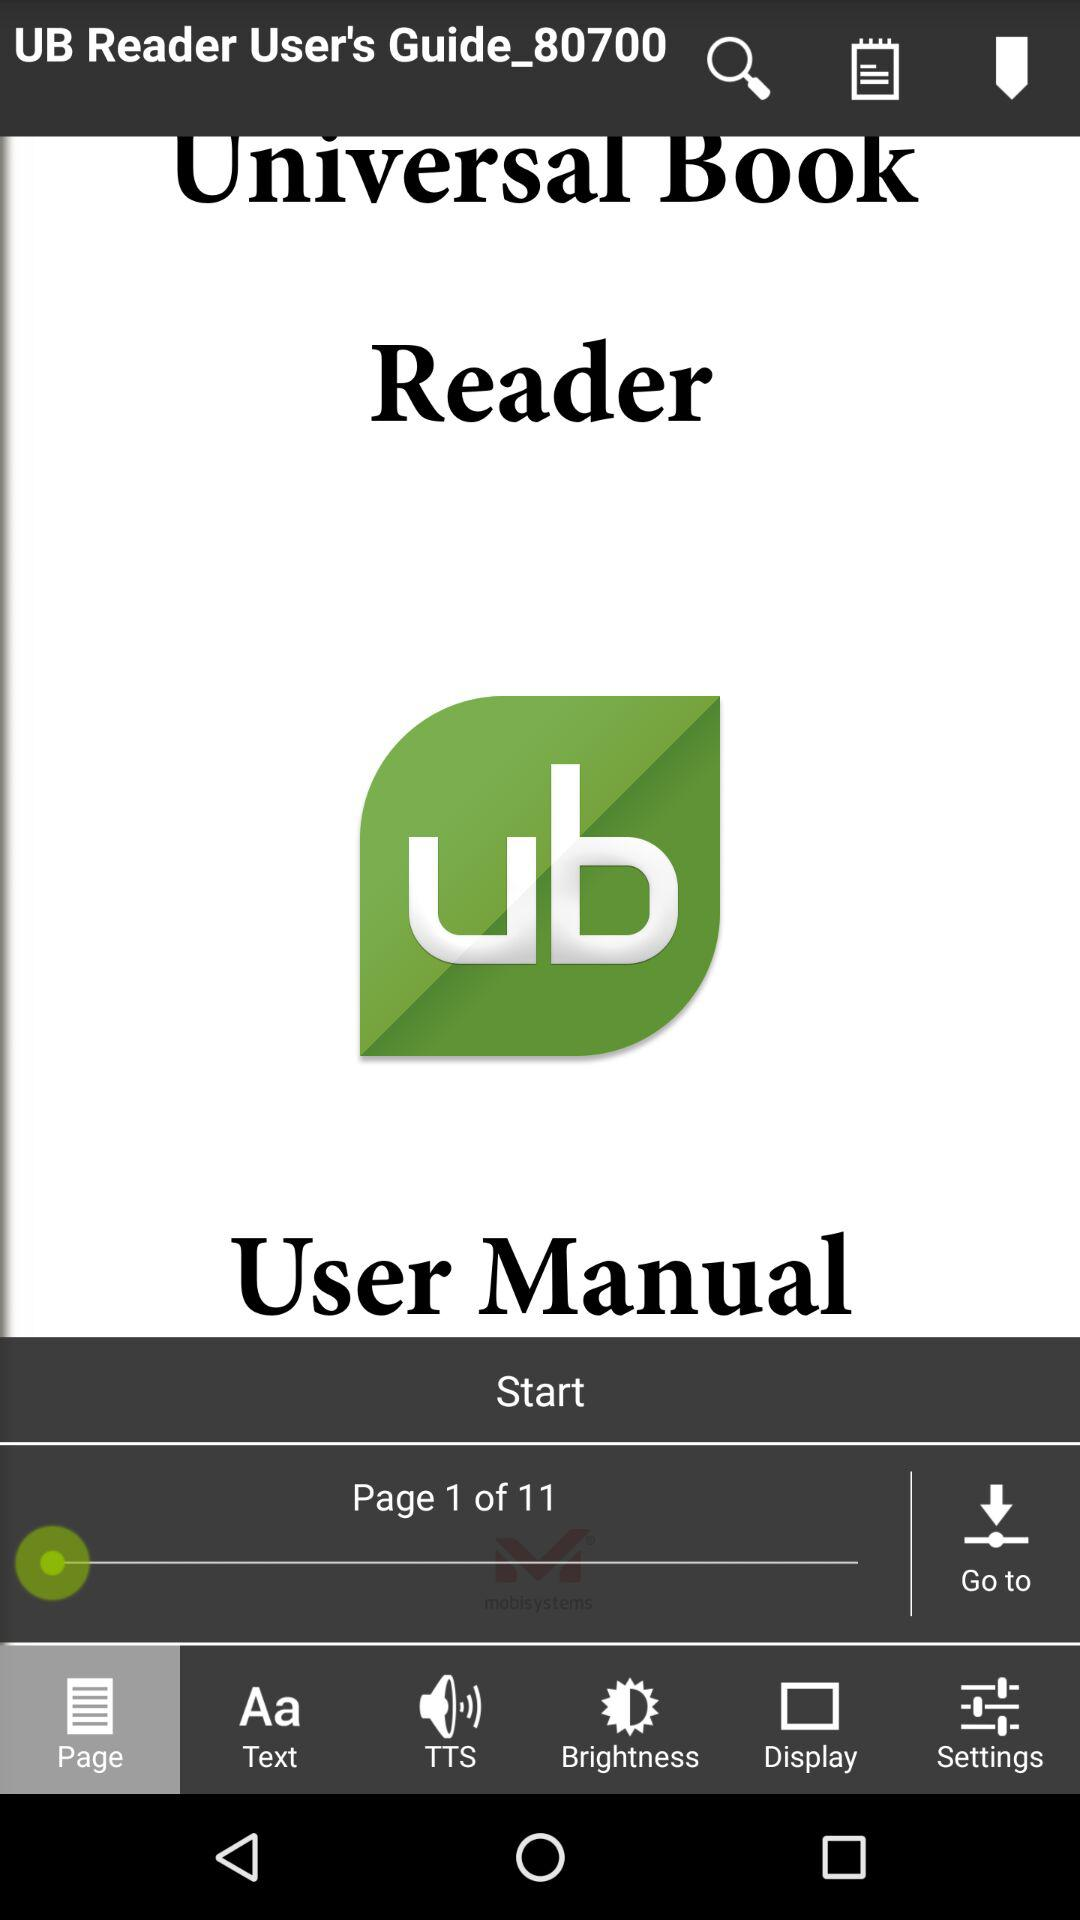Which tab is selected? The selected tab is "Page". 